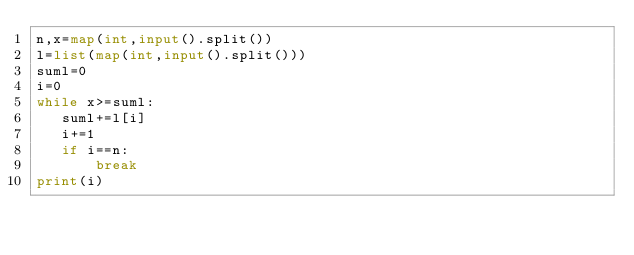Convert code to text. <code><loc_0><loc_0><loc_500><loc_500><_Python_>n,x=map(int,input().split())
l=list(map(int,input().split()))
suml=0
i=0
while x>=suml:
   suml+=l[i]
   i+=1
   if i==n:
       break
print(i)</code> 